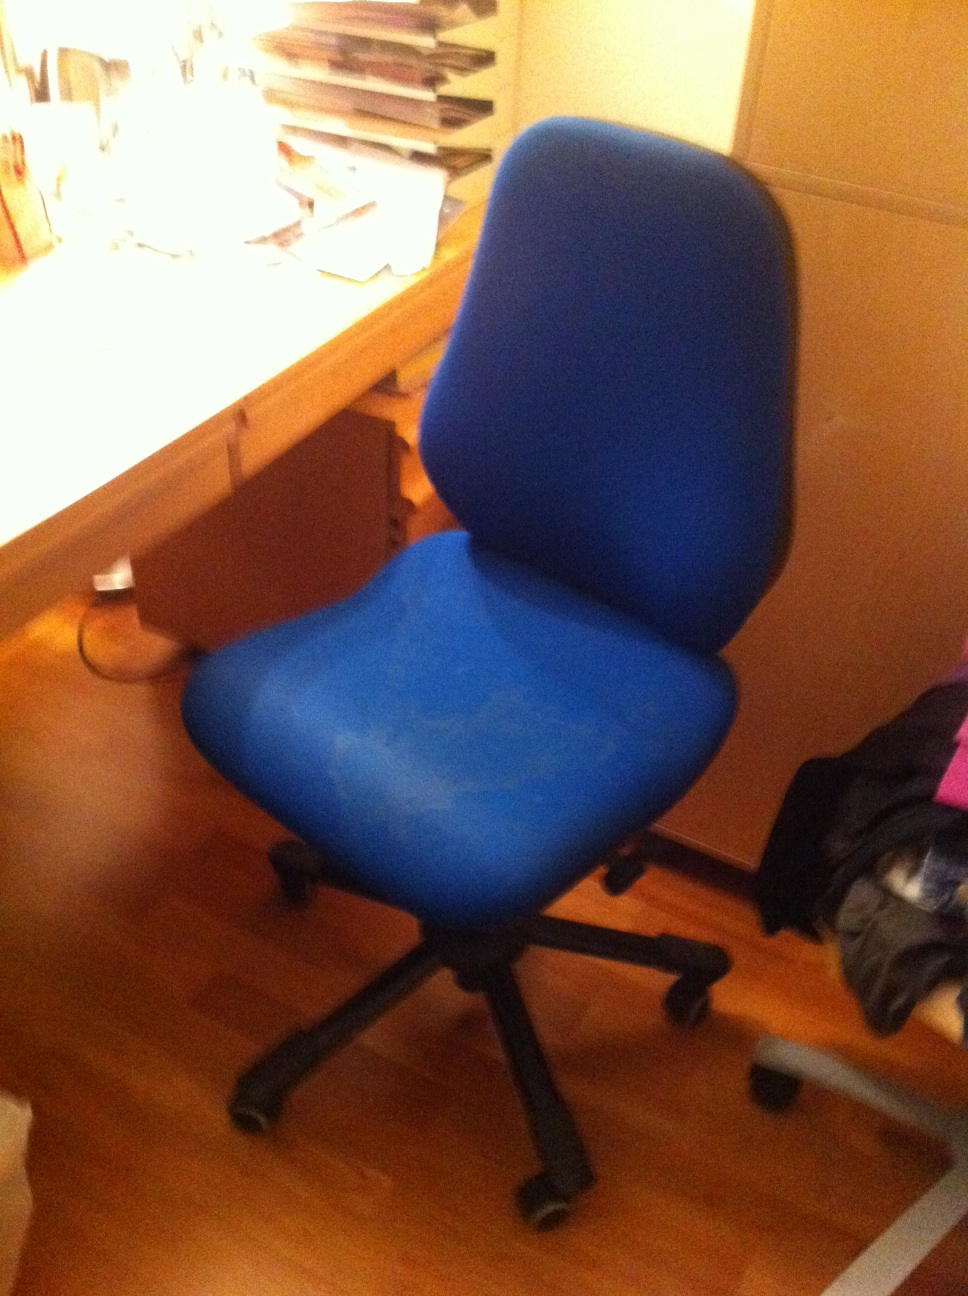Can you describe the setting where this chair is placed? Sure! The blue chair is placed in a home office or study room setting. It's positioned next to a wooden desk that appears to be used for work or study purposes. The desk has several items on top, including a stack of papers, folders, and a lamp providing light. The room has a cozy feel, with a part of another chair visible in the background, indicating it's possibly a shared space for work or relaxation. What are the advantages of having a wheeled chair in this setting? A wheeled chair offers several advantages in a home office or study room setting. Firstly, it allows for easy mobility, making it simple to move around the desk to reach different materials or switch between tasks without having to stand up. This can enhance productivity and comfort, especially during long working or study sessions. Secondly, it provides flexibility, as it can be swiftly moved to a different part of the room if needed. Additionally, the cushioning on the seat and backrest of this particular chair improves ergonomics, which is important for maintaining good posture and reducing strain during prolonged use. 